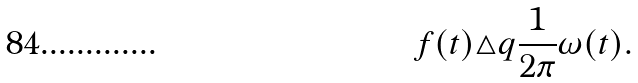<formula> <loc_0><loc_0><loc_500><loc_500>f ( t ) \triangle q { \frac { 1 } { 2 \pi } } \omega ( t ) .</formula> 